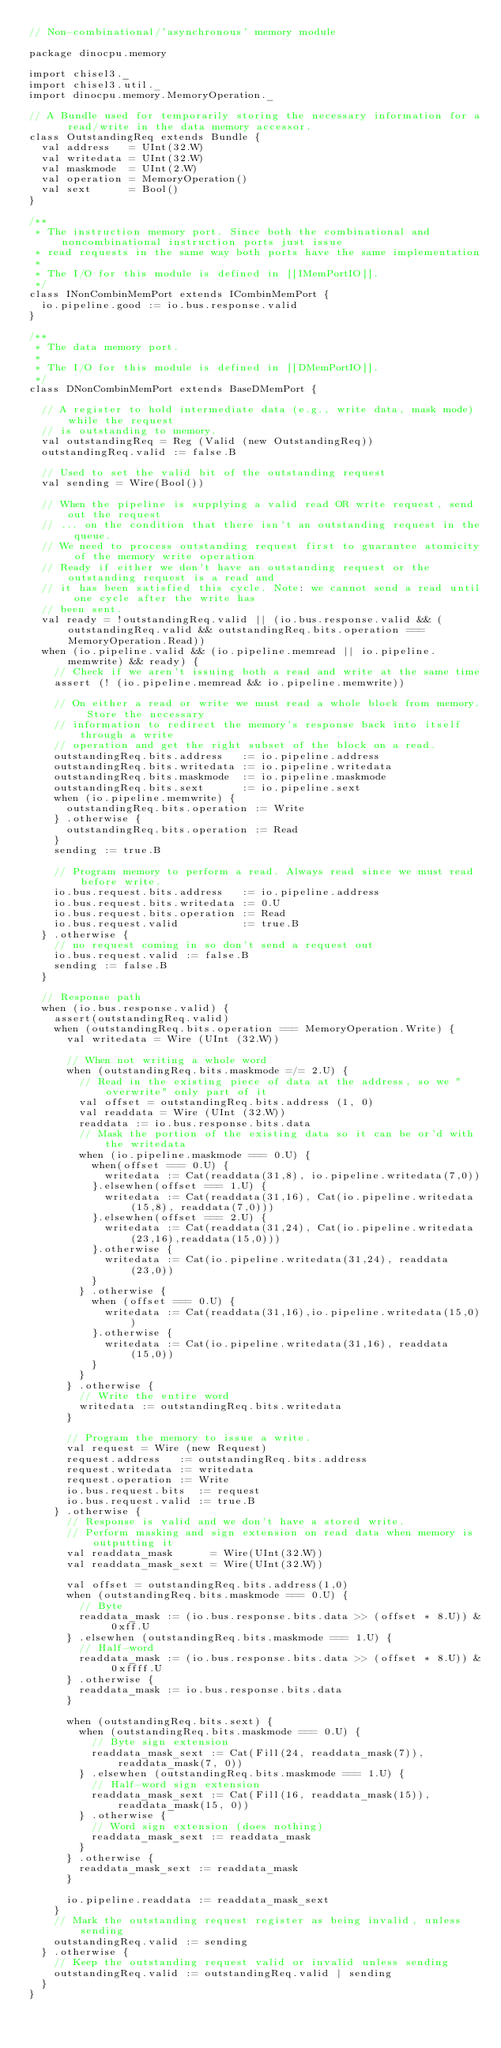<code> <loc_0><loc_0><loc_500><loc_500><_Scala_>// Non-combinational/'asynchronous' memory module

package dinocpu.memory

import chisel3._
import chisel3.util._
import dinocpu.memory.MemoryOperation._

// A Bundle used for temporarily storing the necessary information for a  read/write in the data memory accessor.
class OutstandingReq extends Bundle {
  val address   = UInt(32.W)
  val writedata = UInt(32.W)
  val maskmode  = UInt(2.W)
  val operation = MemoryOperation()
  val sext      = Bool()
}

/**
 * The instruction memory port. Since both the combinational and noncombinational instruction ports just issue
 * read requests in the same way both ports have the same implementation
 *
 * The I/O for this module is defined in [[IMemPortIO]].
 */
class INonCombinMemPort extends ICombinMemPort {
  io.pipeline.good := io.bus.response.valid
}

/**
 * The data memory port.
 *
 * The I/O for this module is defined in [[DMemPortIO]].
 */
class DNonCombinMemPort extends BaseDMemPort {

  // A register to hold intermediate data (e.g., write data, mask mode) while the request
  // is outstanding to memory.
  val outstandingReq = Reg (Valid (new OutstandingReq))
  outstandingReq.valid := false.B

  // Used to set the valid bit of the outstanding request
  val sending = Wire(Bool())

  // When the pipeline is supplying a valid read OR write request, send out the request
  // ... on the condition that there isn't an outstanding request in the queue.
  // We need to process outstanding request first to guarantee atomicity of the memory write operation
  // Ready if either we don't have an outstanding request or the outstanding request is a read and
  // it has been satisfied this cycle. Note: we cannot send a read until one cycle after the write has
  // been sent.
  val ready = !outstandingReq.valid || (io.bus.response.valid && (outstandingReq.valid && outstandingReq.bits.operation === MemoryOperation.Read))
  when (io.pipeline.valid && (io.pipeline.memread || io.pipeline.memwrite) && ready) {
    // Check if we aren't issuing both a read and write at the same time
    assert (! (io.pipeline.memread && io.pipeline.memwrite))

    // On either a read or write we must read a whole block from memory. Store the necessary
    // information to redirect the memory's response back into itself through a write
    // operation and get the right subset of the block on a read.
    outstandingReq.bits.address   := io.pipeline.address
    outstandingReq.bits.writedata := io.pipeline.writedata
    outstandingReq.bits.maskmode  := io.pipeline.maskmode
    outstandingReq.bits.sext      := io.pipeline.sext
    when (io.pipeline.memwrite) {
      outstandingReq.bits.operation := Write
    } .otherwise {
      outstandingReq.bits.operation := Read
    }
    sending := true.B

    // Program memory to perform a read. Always read since we must read before write.
    io.bus.request.bits.address   := io.pipeline.address
    io.bus.request.bits.writedata := 0.U
    io.bus.request.bits.operation := Read
    io.bus.request.valid          := true.B
  } .otherwise {
    // no request coming in so don't send a request out
    io.bus.request.valid := false.B
    sending := false.B
  }

  // Response path
  when (io.bus.response.valid) {
    assert(outstandingReq.valid)
    when (outstandingReq.bits.operation === MemoryOperation.Write) {
      val writedata = Wire (UInt (32.W))

      // When not writing a whole word
      when (outstandingReq.bits.maskmode =/= 2.U) {
        // Read in the existing piece of data at the address, so we "overwrite" only part of it
        val offset = outstandingReq.bits.address (1, 0)
        val readdata = Wire (UInt (32.W))
        readdata := io.bus.response.bits.data
        // Mask the portion of the existing data so it can be or'd with the writedata
        when (io.pipeline.maskmode === 0.U) {
          when(offset === 0.U) {
            writedata := Cat(readdata(31,8), io.pipeline.writedata(7,0))
          }.elsewhen(offset === 1.U) {
            writedata := Cat(readdata(31,16), Cat(io.pipeline.writedata(15,8), readdata(7,0)))
          }.elsewhen(offset === 2.U) {
            writedata := Cat(readdata(31,24), Cat(io.pipeline.writedata(23,16),readdata(15,0)))
          }.otherwise {
            writedata := Cat(io.pipeline.writedata(31,24), readdata(23,0))
          }
        } .otherwise {
          when (offset === 0.U) {
            writedata := Cat(readdata(31,16),io.pipeline.writedata(15,0))
          }.otherwise {
            writedata := Cat(io.pipeline.writedata(31,16), readdata(15,0))
          }
        }
      } .otherwise {
        // Write the entire word
        writedata := outstandingReq.bits.writedata
      }

      // Program the memory to issue a write.
      val request = Wire (new Request)
      request.address   := outstandingReq.bits.address
      request.writedata := writedata
      request.operation := Write
      io.bus.request.bits  := request
      io.bus.request.valid := true.B
    } .otherwise {
      // Response is valid and we don't have a stored write.
      // Perform masking and sign extension on read data when memory is outputting it
      val readdata_mask      = Wire(UInt(32.W))
      val readdata_mask_sext = Wire(UInt(32.W))

      val offset = outstandingReq.bits.address(1,0)
      when (outstandingReq.bits.maskmode === 0.U) {
        // Byte
        readdata_mask := (io.bus.response.bits.data >> (offset * 8.U)) & 0xff.U
      } .elsewhen (outstandingReq.bits.maskmode === 1.U) {
        // Half-word
        readdata_mask := (io.bus.response.bits.data >> (offset * 8.U)) & 0xffff.U
      } .otherwise {
        readdata_mask := io.bus.response.bits.data
      }

      when (outstandingReq.bits.sext) {
        when (outstandingReq.bits.maskmode === 0.U) {
          // Byte sign extension
          readdata_mask_sext := Cat(Fill(24, readdata_mask(7)),  readdata_mask(7, 0))
        } .elsewhen (outstandingReq.bits.maskmode === 1.U) {
          // Half-word sign extension
          readdata_mask_sext := Cat(Fill(16, readdata_mask(15)), readdata_mask(15, 0))
        } .otherwise {
          // Word sign extension (does nothing)
          readdata_mask_sext := readdata_mask
        }
      } .otherwise {
        readdata_mask_sext := readdata_mask
      }

      io.pipeline.readdata := readdata_mask_sext
    }
    // Mark the outstanding request register as being invalid, unless sending
    outstandingReq.valid := sending
  } .otherwise {
    // Keep the outstanding request valid or invalid unless sending
    outstandingReq.valid := outstandingReq.valid | sending
  }
}
</code> 